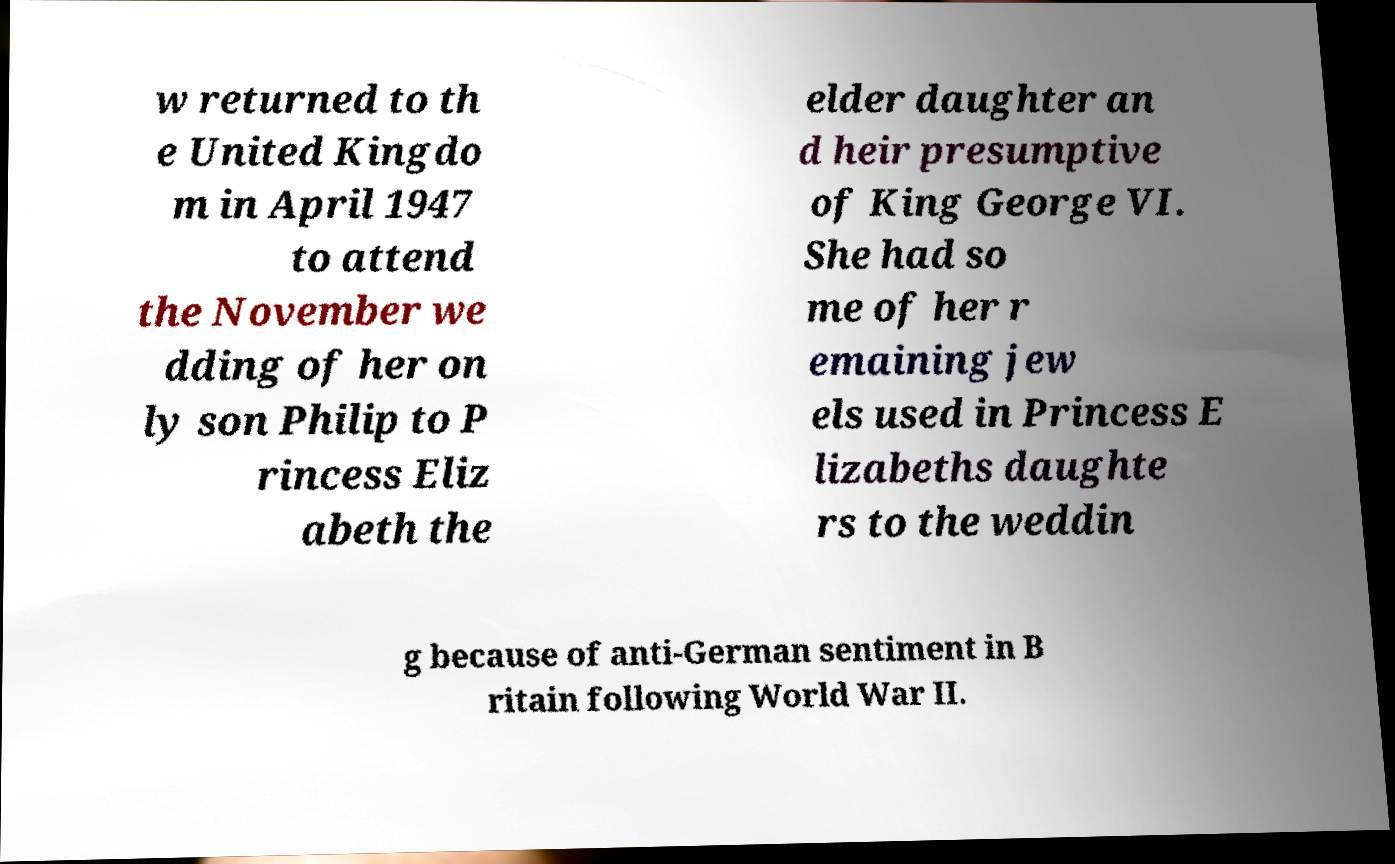For documentation purposes, I need the text within this image transcribed. Could you provide that? w returned to th e United Kingdo m in April 1947 to attend the November we dding of her on ly son Philip to P rincess Eliz abeth the elder daughter an d heir presumptive of King George VI. She had so me of her r emaining jew els used in Princess E lizabeths daughte rs to the weddin g because of anti-German sentiment in B ritain following World War II. 